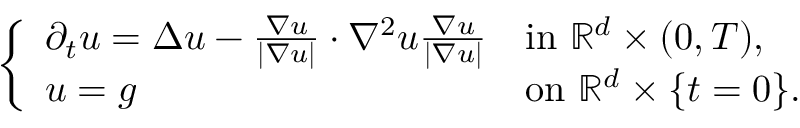Convert formula to latex. <formula><loc_0><loc_0><loc_500><loc_500>\begin{array} { r } { \left \{ \begin{array} { l l } { \partial _ { t } u = \Delta u - \frac { \nabla u } { | \nabla u | } \cdot \nabla ^ { 2 } u \frac { \nabla u } { | \nabla u | } } & { i n \mathbb { R } ^ { d } \times ( 0 , T ) , } \\ { u = g } & { o n \mathbb { R } ^ { d } \times \{ t = 0 \} . } \end{array} } \end{array}</formula> 